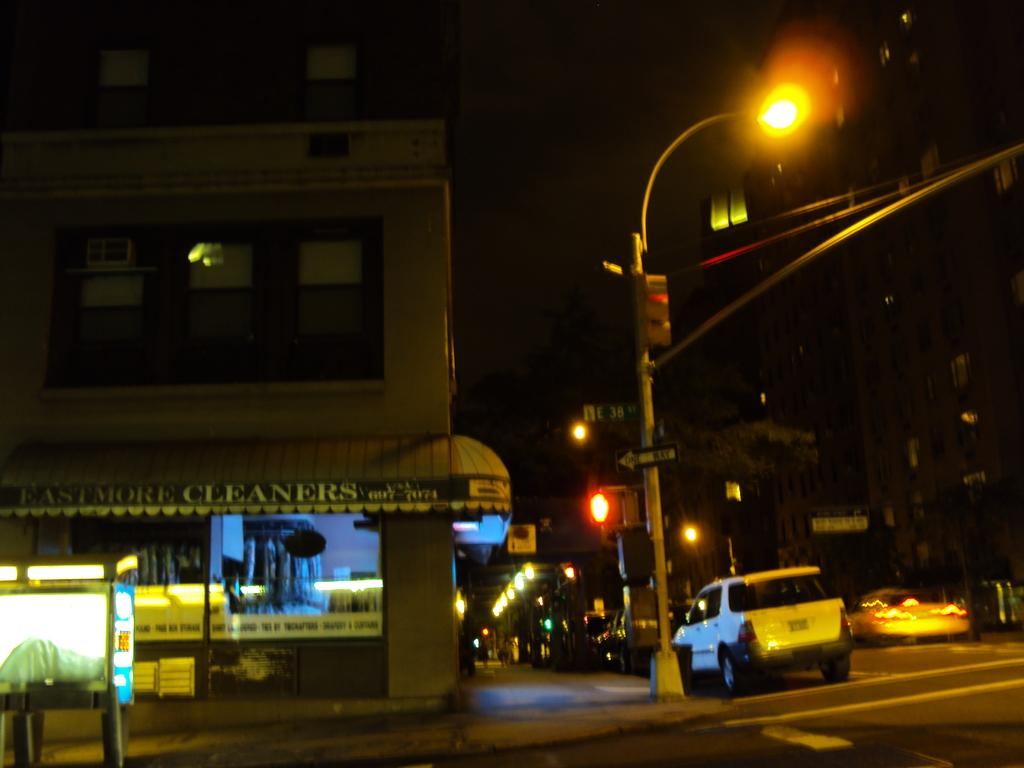<image>
Summarize the visual content of the image. the outside of Eastmore Cleaners at night time 